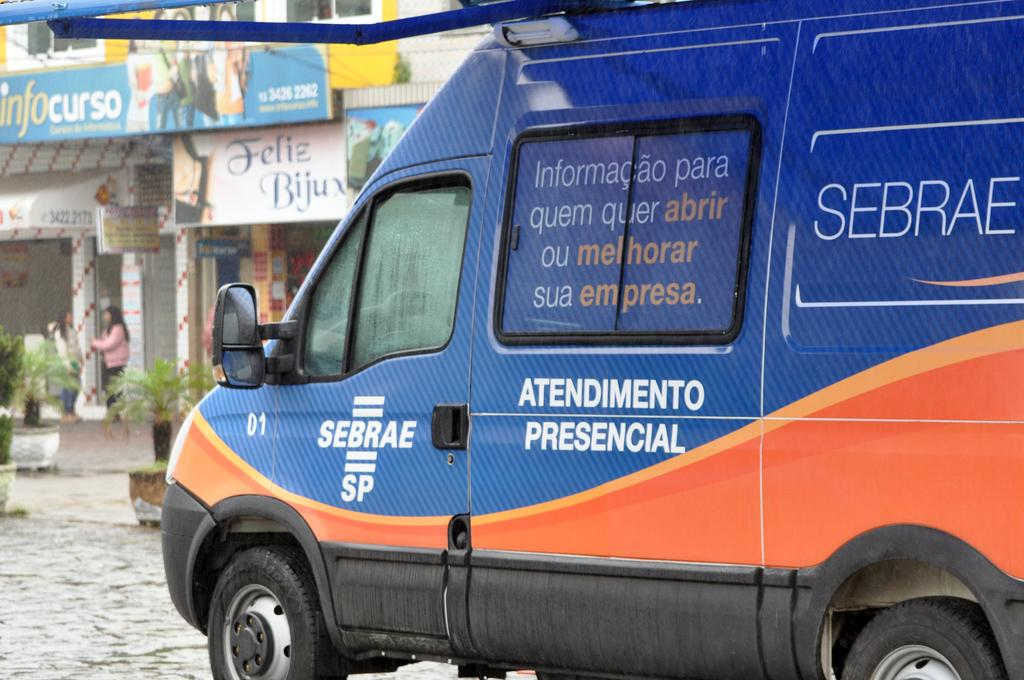<image>
Share a concise interpretation of the image provided. Blue sebrae van riding on a road with buildings 